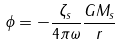<formula> <loc_0><loc_0><loc_500><loc_500>\phi = - { \frac { \zeta _ { s } } { 4 \pi \omega } } { \frac { G M _ { s } } { r } }</formula> 